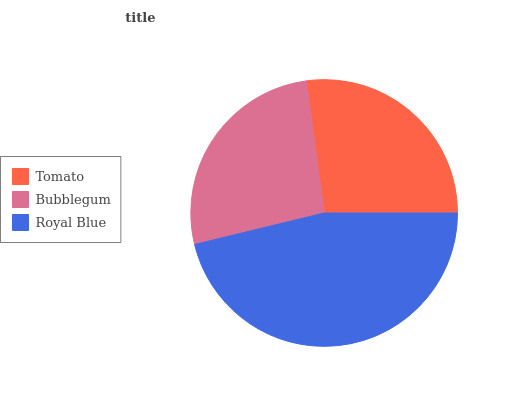Is Bubblegum the minimum?
Answer yes or no. Yes. Is Royal Blue the maximum?
Answer yes or no. Yes. Is Royal Blue the minimum?
Answer yes or no. No. Is Bubblegum the maximum?
Answer yes or no. No. Is Royal Blue greater than Bubblegum?
Answer yes or no. Yes. Is Bubblegum less than Royal Blue?
Answer yes or no. Yes. Is Bubblegum greater than Royal Blue?
Answer yes or no. No. Is Royal Blue less than Bubblegum?
Answer yes or no. No. Is Tomato the high median?
Answer yes or no. Yes. Is Tomato the low median?
Answer yes or no. Yes. Is Royal Blue the high median?
Answer yes or no. No. Is Royal Blue the low median?
Answer yes or no. No. 